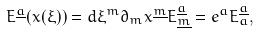Convert formula to latex. <formula><loc_0><loc_0><loc_500><loc_500>E ^ { \underline { a } } ( x ( \xi ) ) = d \xi ^ { m } \partial _ { m } x ^ { \underline { m } } E ^ { \underline { a } } _ { \underline { m } } = e ^ { a } E _ { a } ^ { \underline { a } } ,</formula> 